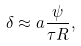Convert formula to latex. <formula><loc_0><loc_0><loc_500><loc_500>\delta \approx a \frac { \psi } { \tau R } ,</formula> 